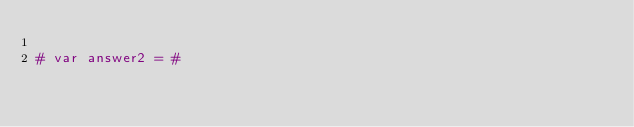<code> <loc_0><loc_0><loc_500><loc_500><_Nim_>
# var answer2 = #
</code> 